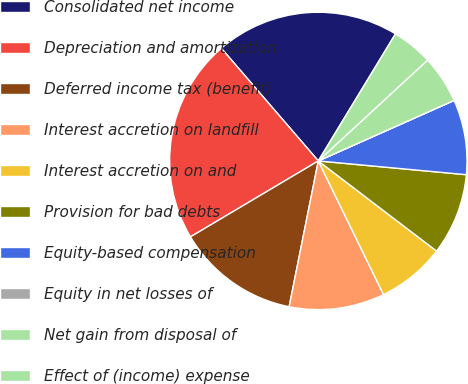Convert chart. <chart><loc_0><loc_0><loc_500><loc_500><pie_chart><fcel>Consolidated net income<fcel>Depreciation and amortization<fcel>Deferred income tax (benefit)<fcel>Interest accretion on landfill<fcel>Interest accretion on and<fcel>Provision for bad debts<fcel>Equity-based compensation<fcel>Equity in net losses of<fcel>Net gain from disposal of<fcel>Effect of (income) expense<nl><fcel>20.0%<fcel>22.22%<fcel>13.33%<fcel>10.37%<fcel>7.41%<fcel>8.89%<fcel>8.15%<fcel>0.0%<fcel>5.19%<fcel>4.45%<nl></chart> 